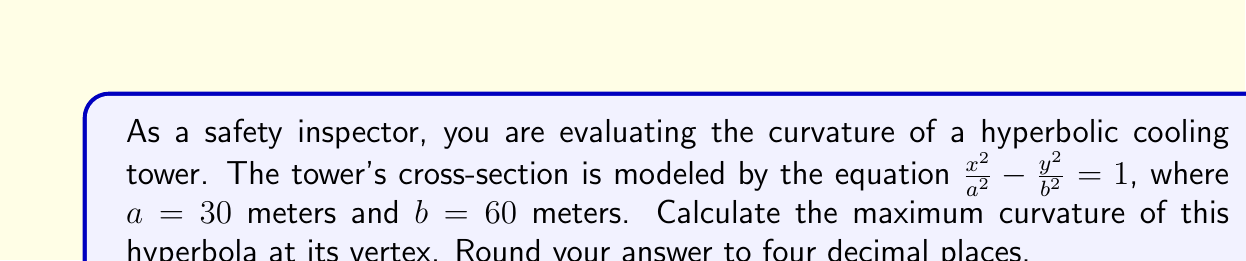Help me with this question. To solve this problem, we'll follow these steps:

1) The general equation of a hyperbola is $\frac{x^2}{a^2} - \frac{y^2}{b^2} = 1$, where $a$ and $b$ are given as 30 and 60 meters respectively.

2) For a hyperbola with this equation, the maximum curvature occurs at the vertex $(a,0)$.

3) The formula for the curvature of a hyperbola at any point is:

   $$K = \frac{ab}{(a^2\sinh^2 t + b^2\cosh^2 t)^{3/2}}$$

   where $t$ is the parameter in the parametric equations of the hyperbola:
   $x = a\cosh t$, $y = b\sinh t$

4) At the vertex $(a,0)$, $t = 0$ because $\cosh 0 = 1$ and $\sinh 0 = 0$.

5) Substituting $t = 0$ into the curvature formula:

   $$K_{max} = \frac{ab}{(a^2 \cdot 0^2 + b^2 \cdot 1^2)^{3/2}} = \frac{ab}{b^3} = \frac{a}{b^2}$$

6) Now we can substitute our values:

   $$K_{max} = \frac{30}{60^2} = \frac{30}{3600} = \frac{1}{120} \approx 0.0083$$

7) Rounding to four decimal places gives us 0.0083.

This maximum curvature value is crucial for assessing the structural integrity and safety of the cooling tower, as it represents the point of greatest stress on the tower's shape.
Answer: 0.0083 